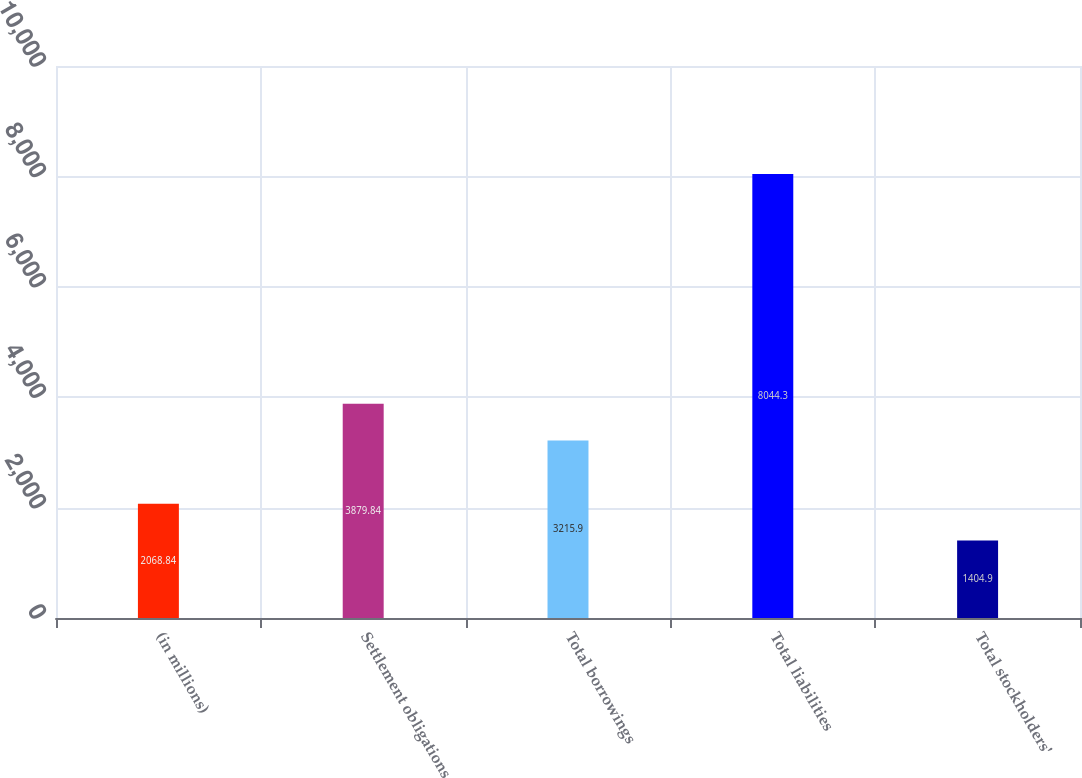<chart> <loc_0><loc_0><loc_500><loc_500><bar_chart><fcel>(in millions)<fcel>Settlement obligations<fcel>Total borrowings<fcel>Total liabilities<fcel>Total stockholders'<nl><fcel>2068.84<fcel>3879.84<fcel>3215.9<fcel>8044.3<fcel>1404.9<nl></chart> 